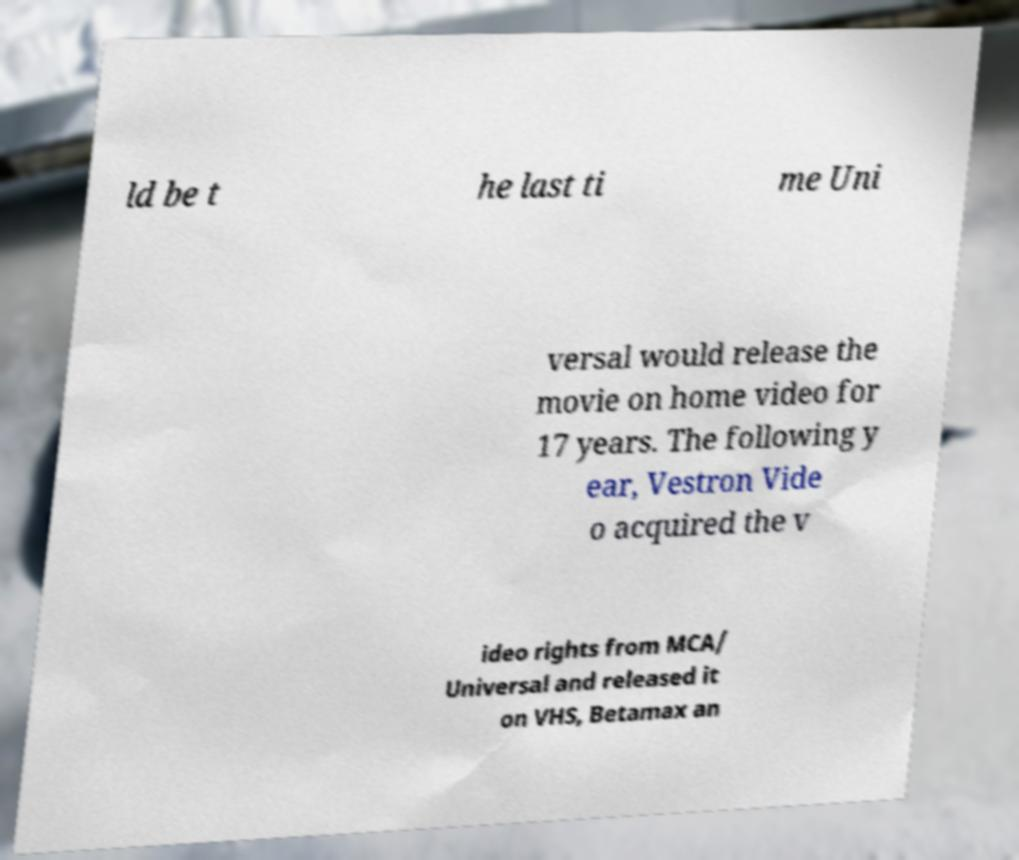Can you read and provide the text displayed in the image?This photo seems to have some interesting text. Can you extract and type it out for me? ld be t he last ti me Uni versal would release the movie on home video for 17 years. The following y ear, Vestron Vide o acquired the v ideo rights from MCA/ Universal and released it on VHS, Betamax an 